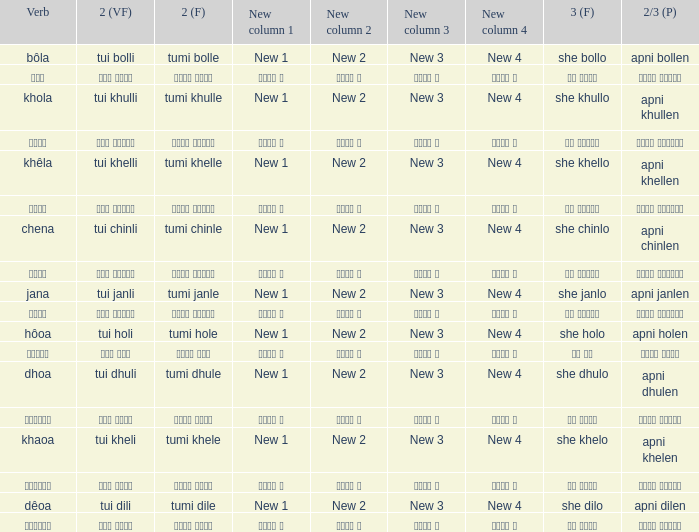Can you parse all the data within this table? {'header': ['Verb', '2 (VF)', '2 (F)', 'New column 1', 'New column 2', 'New column 3', 'New column 4', '3 (F)', '2/3 (P)'], 'rows': [['bôla', 'tui bolli', 'tumi bolle', 'New 1', 'New 2', 'New 3', 'New 4', 'she bollo', 'apni bollen'], ['বলা', 'তুই বললি', 'তুমি বললে', 'নতুন ১', 'নতুন ২', 'নতুন ৩', 'নতুন ৪', 'সে বললো', 'আপনি বললেন'], ['khola', 'tui khulli', 'tumi khulle', 'New 1', 'New 2', 'New 3', 'New 4', 'she khullo', 'apni khullen'], ['খোলা', 'তুই খুললি', 'তুমি খুললে', 'নতুন ১', 'নতুন ২', 'নতুন ৩', 'নতুন ৪', 'সে খুললো', 'আপনি খুললেন'], ['khêla', 'tui khelli', 'tumi khelle', 'New 1', 'New 2', 'New 3', 'New 4', 'she khello', 'apni khellen'], ['খেলে', 'তুই খেললি', 'তুমি খেললে', 'নতুন ১', 'নতুন ২', 'নতুন ৩', 'নতুন ৪', 'সে খেললো', 'আপনি খেললেন'], ['chena', 'tui chinli', 'tumi chinle', 'New 1', 'New 2', 'New 3', 'New 4', 'she chinlo', 'apni chinlen'], ['চেনা', 'তুই চিনলি', 'তুমি চিনলে', 'নতুন ১', 'নতুন ২', 'নতুন ৩', 'নতুন ৪', 'সে চিনলো', 'আপনি চিনলেন'], ['jana', 'tui janli', 'tumi janle', 'New 1', 'New 2', 'New 3', 'New 4', 'she janlo', 'apni janlen'], ['জানা', 'তুই জানলি', 'তুমি জানলে', 'নতুন ১', 'নতুন ২', 'নতুন ৩', 'নতুন ৪', 'সে জানলে', 'আপনি জানলেন'], ['hôoa', 'tui holi', 'tumi hole', 'New 1', 'New 2', 'New 3', 'New 4', 'she holo', 'apni holen'], ['হওয়া', 'তুই হলি', 'তুমি হলে', 'নতুন ১', 'নতুন ২', 'নতুন ৩', 'নতুন ৪', 'সে হল', 'আপনি হলেন'], ['dhoa', 'tui dhuli', 'tumi dhule', 'New 1', 'New 2', 'New 3', 'New 4', 'she dhulo', 'apni dhulen'], ['ধোওয়া', 'তুই ধুলি', 'তুমি ধুলে', 'নতুন ১', 'নতুন ২', 'নতুন ৩', 'নতুন ৪', 'সে ধুলো', 'আপনি ধুলেন'], ['khaoa', 'tui kheli', 'tumi khele', 'New 1', 'New 2', 'New 3', 'New 4', 'she khelo', 'apni khelen'], ['খাওয়া', 'তুই খেলি', 'তুমি খেলে', 'নতুন ১', 'নতুন ২', 'নতুন ৩', 'নতুন ৪', 'সে খেলো', 'আপনি খেলেন'], ['dêoa', 'tui dili', 'tumi dile', 'New 1', 'New 2', 'New 3', 'New 4', 'she dilo', 'apni dilen'], ['দেওয়া', 'তুই দিলি', 'তুমি দিলে', 'নতুন ১', 'নতুন ২', 'নতুন ৩', 'নতুন ৪', 'সে দিলো', 'আপনি দিলেন']]} What is the verb associated with তুমি খেলে? খাওয়া. 